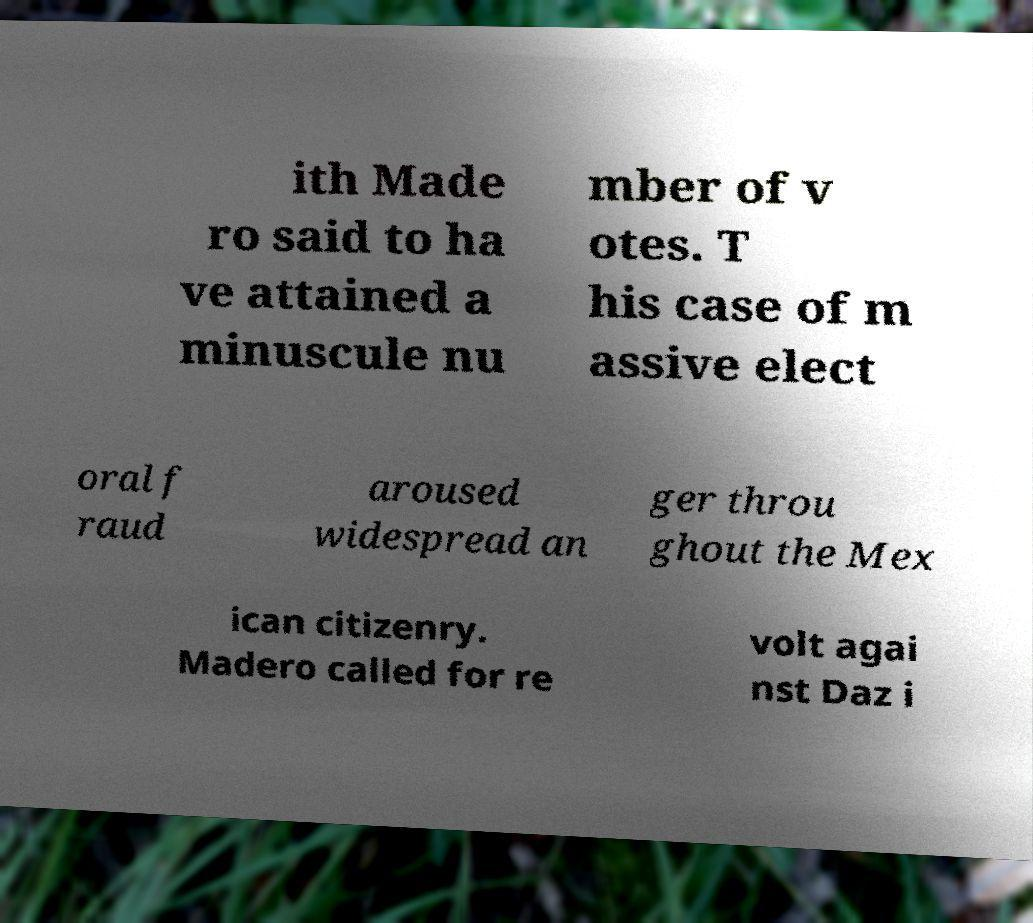Could you assist in decoding the text presented in this image and type it out clearly? ith Made ro said to ha ve attained a minuscule nu mber of v otes. T his case of m assive elect oral f raud aroused widespread an ger throu ghout the Mex ican citizenry. Madero called for re volt agai nst Daz i 